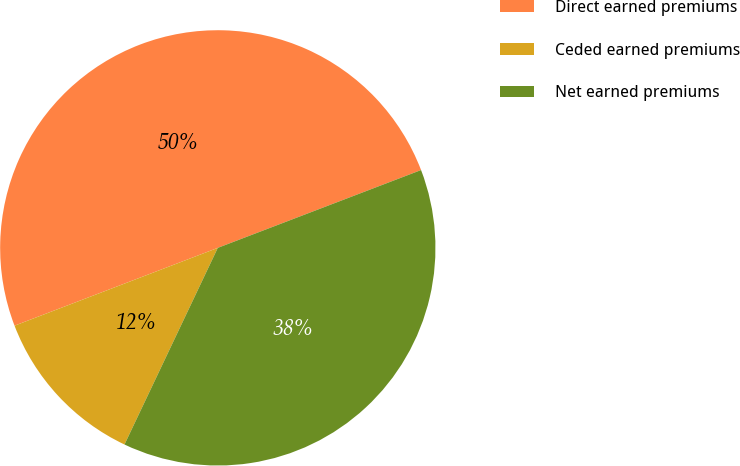<chart> <loc_0><loc_0><loc_500><loc_500><pie_chart><fcel>Direct earned premiums<fcel>Ceded earned premiums<fcel>Net earned premiums<nl><fcel>50.0%<fcel>12.13%<fcel>37.87%<nl></chart> 